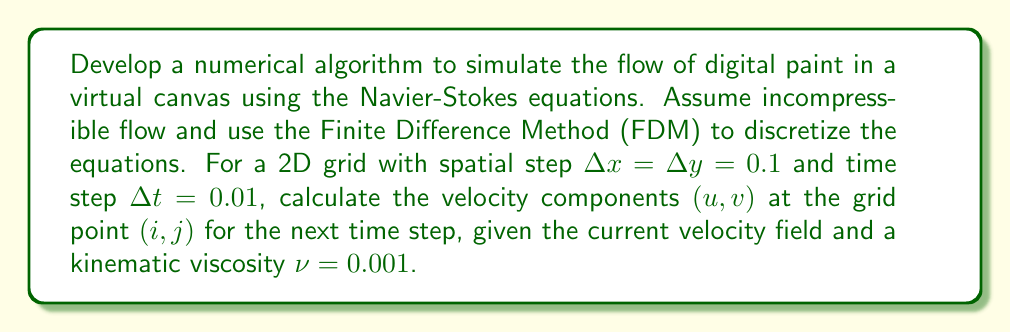Solve this math problem. To simulate fluid dynamics for digital paint, we'll use the incompressible Navier-Stokes equations in 2D:

1. Continuity equation:
   $$\frac{\partial u}{\partial x} + \frac{\partial v}{\partial y} = 0$$

2. Momentum equations:
   $$\frac{\partial u}{\partial t} + u\frac{\partial u}{\partial x} + v\frac{\partial u}{\partial y} = -\frac{1}{\rho}\frac{\partial p}{\partial x} + \nu\left(\frac{\partial^2 u}{\partial x^2} + \frac{\partial^2 u}{\partial y^2}\right)$$
   $$\frac{\partial v}{\partial t} + u\frac{\partial v}{\partial x} + v\frac{\partial v}{\partial y} = -\frac{1}{\rho}\frac{\partial p}{\partial y} + \nu\left(\frac{\partial^2 v}{\partial x^2} + \frac{\partial^2 v}{\partial y^2}\right)$$

Using FDM, we'll discretize these equations:

3. Discretize spatial derivatives using central differences:
   $$\frac{\partial u}{\partial x} \approx \frac{u_{i+1,j} - u_{i-1,j}}{2\Delta x}$$
   $$\frac{\partial^2 u}{\partial x^2} \approx \frac{u_{i+1,j} - 2u_{i,j} + u_{i-1,j}}{\Delta x^2}$$

4. Discretize time derivative using forward difference:
   $$\frac{\partial u}{\partial t} \approx \frac{u_{i,j}^{n+1} - u_{i,j}^n}{\Delta t}$$

5. Apply discretization to the momentum equation for $u$:
   $$\frac{u_{i,j}^{n+1} - u_{i,j}^n}{\Delta t} + u_{i,j}^n\frac{u_{i+1,j}^n - u_{i-1,j}^n}{2\Delta x} + v_{i,j}^n\frac{u_{i,j+1}^n - u_{i,j-1}^n}{2\Delta y} = -\frac{1}{\rho}\frac{p_{i+1,j}^n - p_{i-1,j}^n}{2\Delta x} + \nu\left(\frac{u_{i+1,j}^n - 2u_{i,j}^n + u_{i-1,j}^n}{\Delta x^2} + \frac{u_{i,j+1}^n - 2u_{i,j}^n + u_{i,j-1}^n}{\Delta y^2}\right)$$

6. Solve for $u_{i,j}^{n+1}$:
   $$u_{i,j}^{n+1} = u_{i,j}^n + \Delta t\left[-u_{i,j}^n\frac{u_{i+1,j}^n - u_{i-1,j}^n}{2\Delta x} - v_{i,j}^n\frac{u_{i,j+1}^n - u_{i,j-1}^n}{2\Delta y} - \frac{1}{\rho}\frac{p_{i+1,j}^n - p_{i-1,j}^n}{2\Delta x} + \nu\left(\frac{u_{i+1,j}^n - 2u_{i,j}^n + u_{i-1,j}^n}{\Delta x^2} + \frac{u_{i,j+1}^n - 2u_{i,j}^n + u_{i,j-1}^n}{\Delta y^2}\right)\right]$$

7. Similarly, derive the equation for $v_{i,j}^{n+1}$.

8. Substitute the given values: $\Delta x = \Delta y = 0.1$, $\Delta t = 0.01$, and $\nu = 0.001$.

9. Implement the algorithm:
   a. Initialize the velocity field $(u, v)$ and pressure field $p$.
   b. For each time step:
      - Update boundary conditions.
      - Solve for pressure using the Poisson equation.
      - Update velocity components using the derived equations.
      - Enforce the continuity equation to ensure incompressibility.

This algorithm provides a numerical simulation of fluid dynamics for digital paint, allowing artists to create realistic fluid effects in their digital illustrations.
Answer: FDM discretization of Navier-Stokes equations with explicit time-stepping 